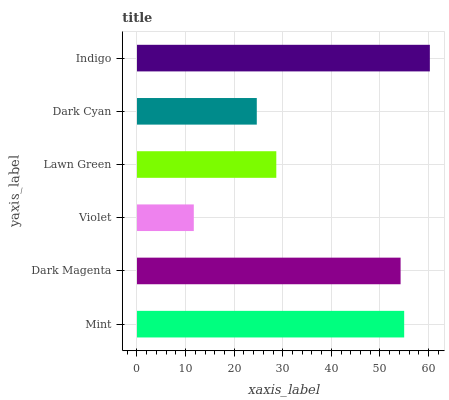Is Violet the minimum?
Answer yes or no. Yes. Is Indigo the maximum?
Answer yes or no. Yes. Is Dark Magenta the minimum?
Answer yes or no. No. Is Dark Magenta the maximum?
Answer yes or no. No. Is Mint greater than Dark Magenta?
Answer yes or no. Yes. Is Dark Magenta less than Mint?
Answer yes or no. Yes. Is Dark Magenta greater than Mint?
Answer yes or no. No. Is Mint less than Dark Magenta?
Answer yes or no. No. Is Dark Magenta the high median?
Answer yes or no. Yes. Is Lawn Green the low median?
Answer yes or no. Yes. Is Violet the high median?
Answer yes or no. No. Is Indigo the low median?
Answer yes or no. No. 